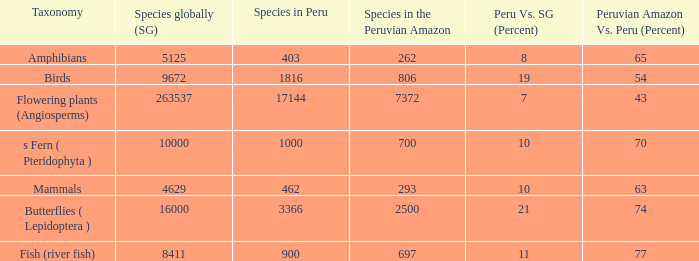In terms of percentage, which species has a 63% occurrence in the peruvian amazon compared to the rest of peru? 4629.0. 